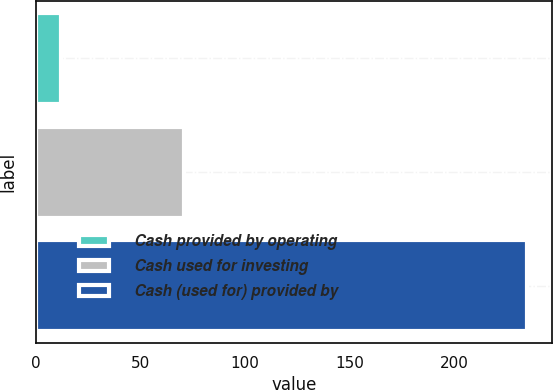Convert chart. <chart><loc_0><loc_0><loc_500><loc_500><bar_chart><fcel>Cash provided by operating<fcel>Cash used for investing<fcel>Cash (used for) provided by<nl><fcel>12<fcel>71<fcel>235<nl></chart> 